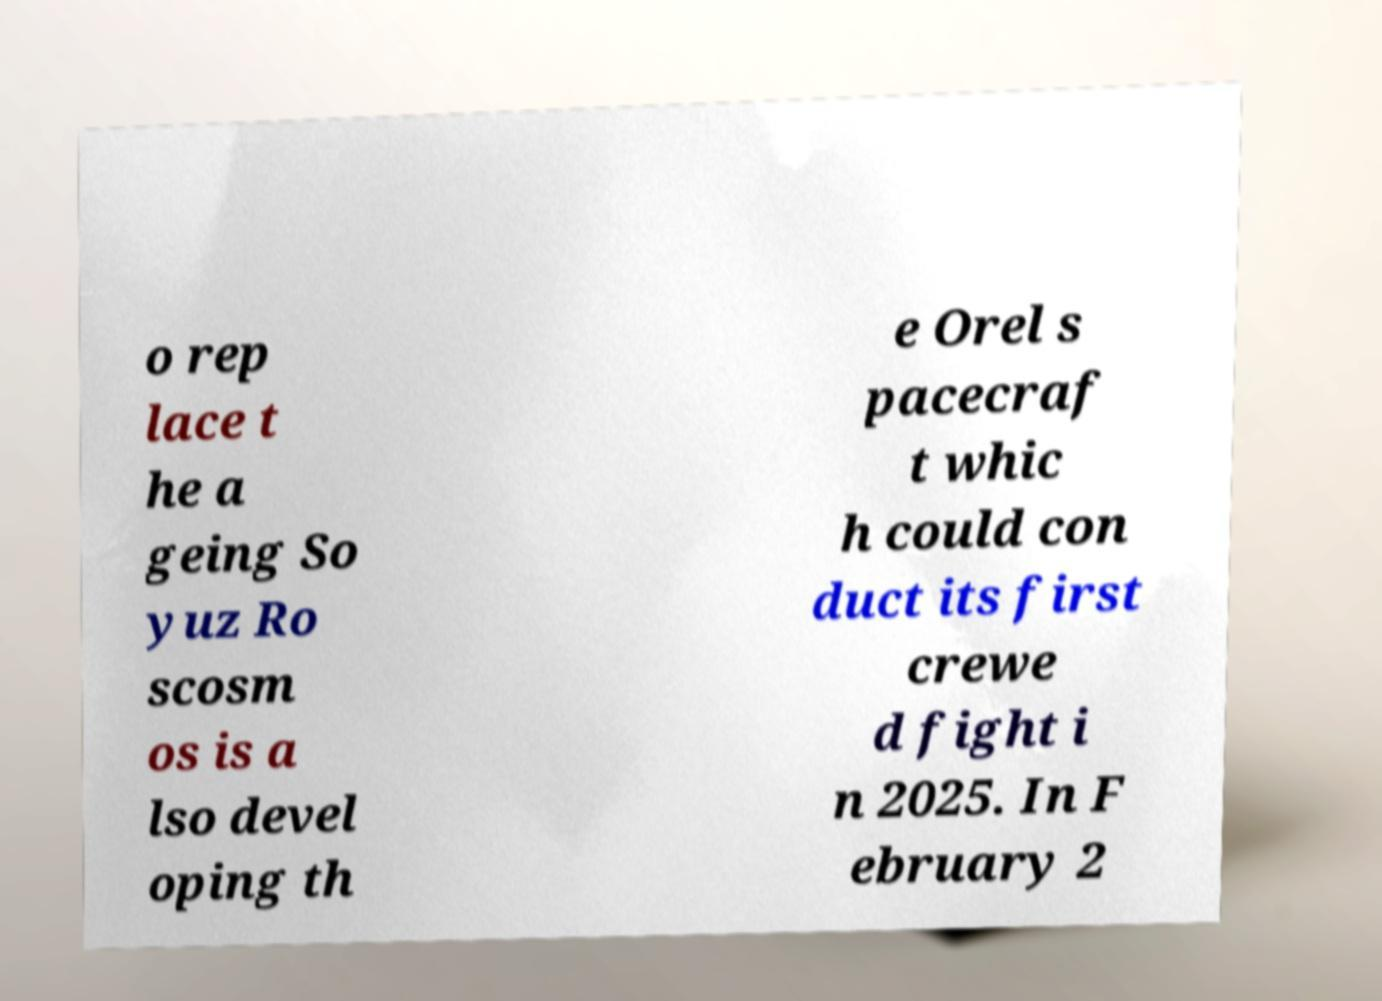For documentation purposes, I need the text within this image transcribed. Could you provide that? o rep lace t he a geing So yuz Ro scosm os is a lso devel oping th e Orel s pacecraf t whic h could con duct its first crewe d fight i n 2025. In F ebruary 2 